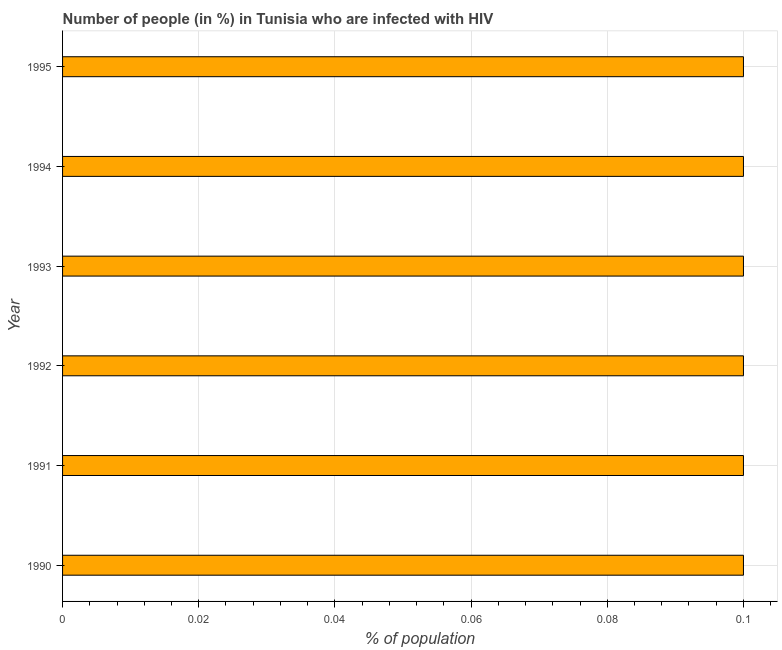Does the graph contain grids?
Offer a terse response. Yes. What is the title of the graph?
Provide a short and direct response. Number of people (in %) in Tunisia who are infected with HIV. What is the label or title of the X-axis?
Offer a very short reply. % of population. Across all years, what is the maximum number of people infected with hiv?
Your answer should be compact. 0.1. In which year was the number of people infected with hiv maximum?
Make the answer very short. 1990. In which year was the number of people infected with hiv minimum?
Keep it short and to the point. 1990. What is the sum of the number of people infected with hiv?
Make the answer very short. 0.6. What is the difference between the number of people infected with hiv in 1990 and 1994?
Provide a succinct answer. 0. What is the average number of people infected with hiv per year?
Keep it short and to the point. 0.1. In how many years, is the number of people infected with hiv greater than 0.028 %?
Your answer should be compact. 6. Is the number of people infected with hiv in 1991 less than that in 1992?
Your answer should be very brief. No. Is the difference between the number of people infected with hiv in 1990 and 1991 greater than the difference between any two years?
Offer a terse response. Yes. What is the difference between the highest and the second highest number of people infected with hiv?
Make the answer very short. 0. Is the sum of the number of people infected with hiv in 1993 and 1994 greater than the maximum number of people infected with hiv across all years?
Your answer should be very brief. Yes. What is the difference between the highest and the lowest number of people infected with hiv?
Offer a terse response. 0. In how many years, is the number of people infected with hiv greater than the average number of people infected with hiv taken over all years?
Your answer should be compact. 6. How many years are there in the graph?
Keep it short and to the point. 6. What is the difference between two consecutive major ticks on the X-axis?
Keep it short and to the point. 0.02. Are the values on the major ticks of X-axis written in scientific E-notation?
Give a very brief answer. No. What is the % of population of 1990?
Offer a terse response. 0.1. What is the % of population in 1991?
Provide a succinct answer. 0.1. What is the % of population in 1993?
Your answer should be very brief. 0.1. What is the % of population of 1994?
Provide a short and direct response. 0.1. What is the difference between the % of population in 1990 and 1991?
Ensure brevity in your answer.  0. What is the difference between the % of population in 1991 and 1994?
Offer a terse response. 0. What is the difference between the % of population in 1991 and 1995?
Your answer should be compact. 0. What is the difference between the % of population in 1992 and 1995?
Your answer should be very brief. 0. What is the difference between the % of population in 1993 and 1994?
Offer a very short reply. 0. What is the difference between the % of population in 1993 and 1995?
Your response must be concise. 0. What is the ratio of the % of population in 1990 to that in 1992?
Give a very brief answer. 1. What is the ratio of the % of population in 1990 to that in 1995?
Your answer should be compact. 1. What is the ratio of the % of population in 1991 to that in 1993?
Your answer should be very brief. 1. What is the ratio of the % of population in 1991 to that in 1994?
Your answer should be very brief. 1. What is the ratio of the % of population in 1991 to that in 1995?
Keep it short and to the point. 1. What is the ratio of the % of population in 1992 to that in 1993?
Ensure brevity in your answer.  1. What is the ratio of the % of population in 1992 to that in 1994?
Provide a succinct answer. 1. What is the ratio of the % of population in 1994 to that in 1995?
Keep it short and to the point. 1. 